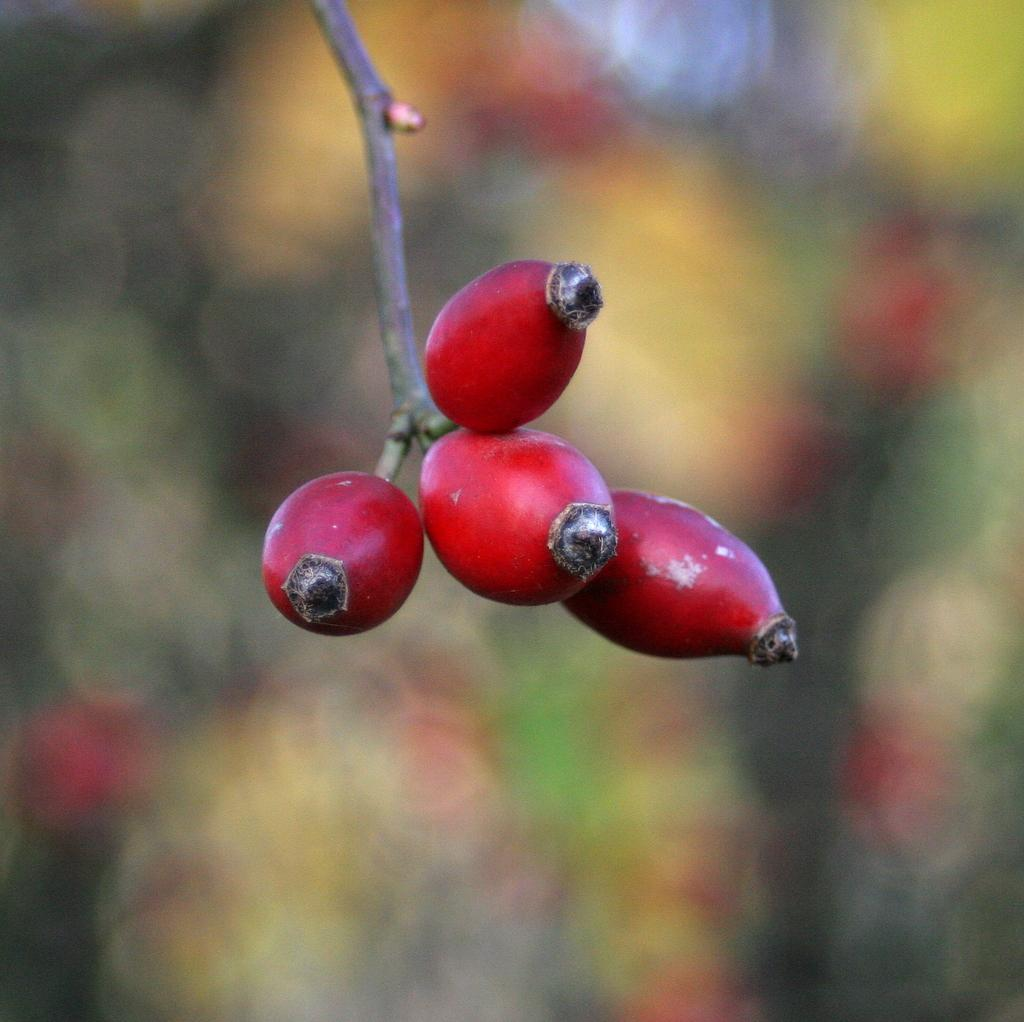What type of food can be seen in the image? There are fruits on a stem in the image. Can you describe the background of the image? The background of the image is blurry. What type of sound can be heard coming from the calendar in the image? There is no calendar present in the image, and therefore no sound can be heard from it. 